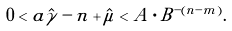<formula> <loc_0><loc_0><loc_500><loc_500>0 < a \hat { \gamma } - n + \hat { \mu } < A \cdot B ^ { - ( n - m ) } .</formula> 